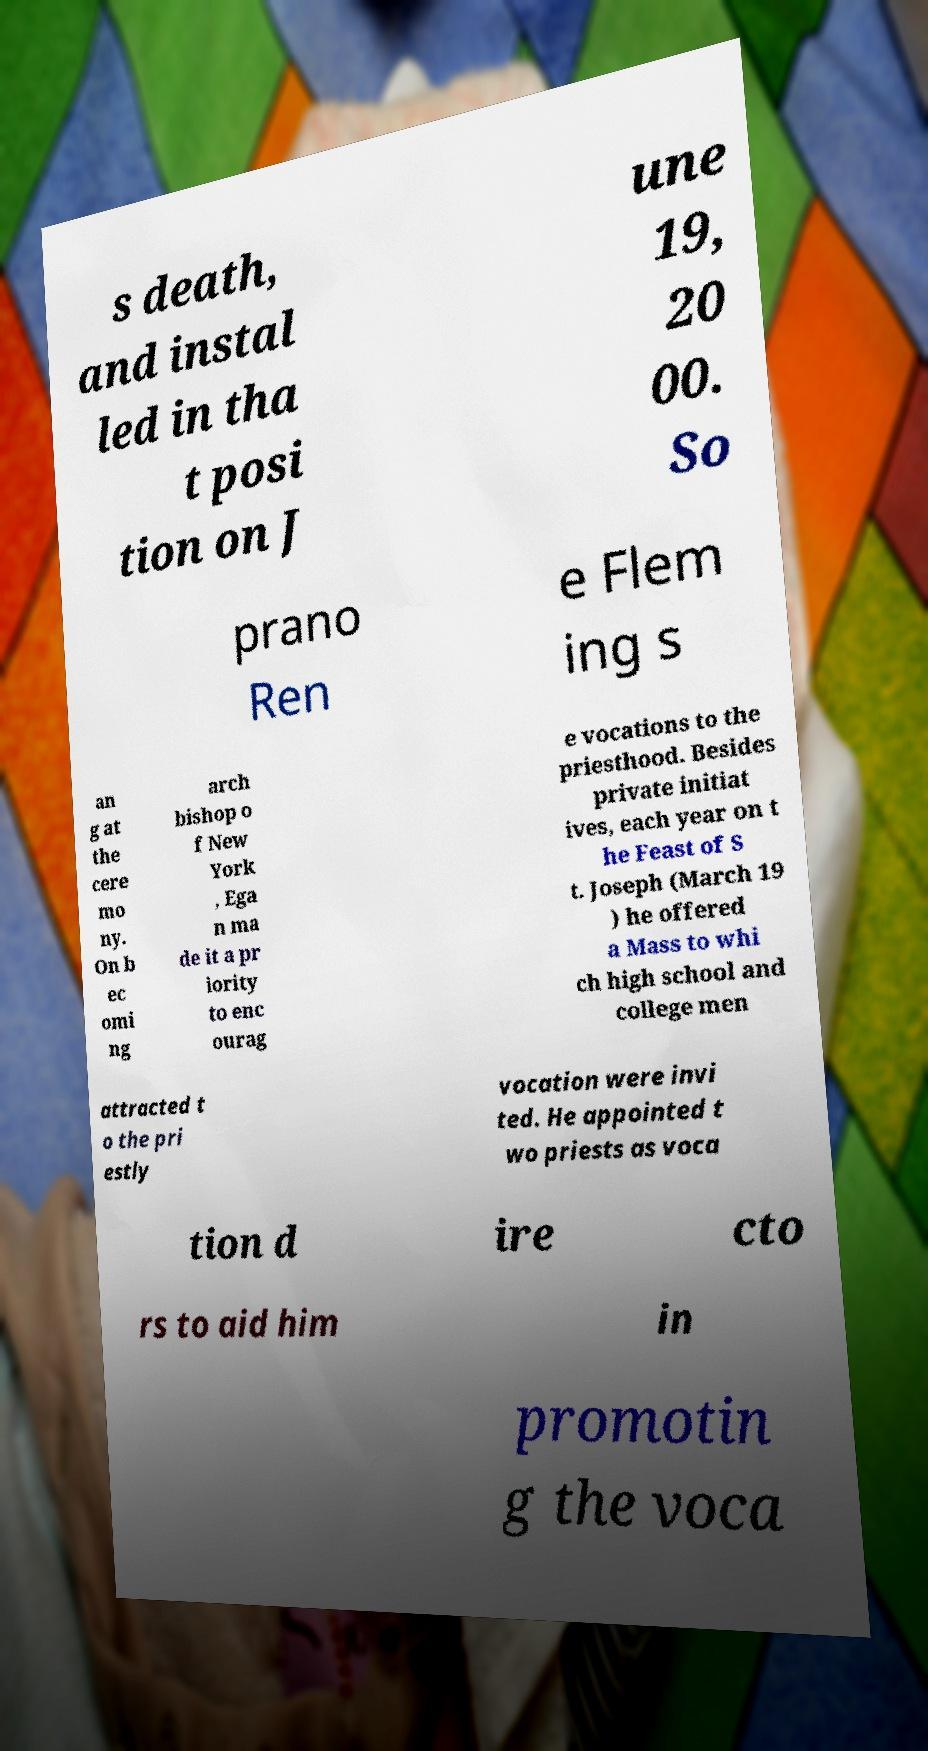I need the written content from this picture converted into text. Can you do that? s death, and instal led in tha t posi tion on J une 19, 20 00. So prano Ren e Flem ing s an g at the cere mo ny. On b ec omi ng arch bishop o f New York , Ega n ma de it a pr iority to enc ourag e vocations to the priesthood. Besides private initiat ives, each year on t he Feast of S t. Joseph (March 19 ) he offered a Mass to whi ch high school and college men attracted t o the pri estly vocation were invi ted. He appointed t wo priests as voca tion d ire cto rs to aid him in promotin g the voca 